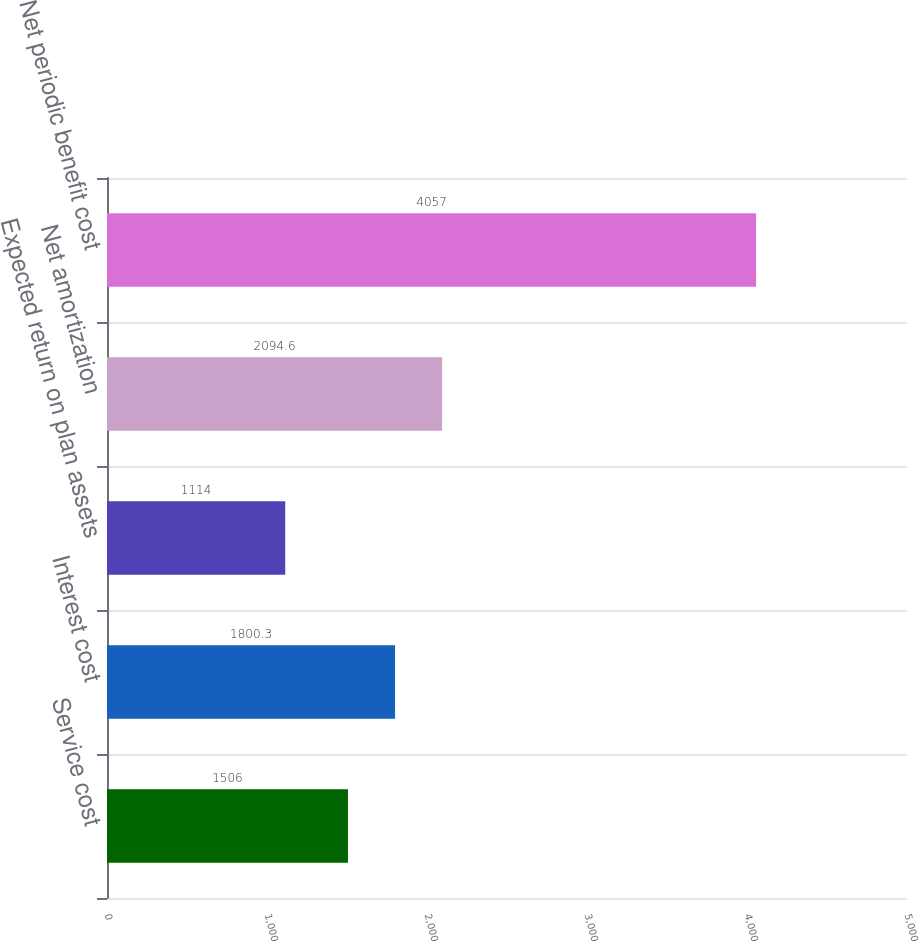Convert chart. <chart><loc_0><loc_0><loc_500><loc_500><bar_chart><fcel>Service cost<fcel>Interest cost<fcel>Expected return on plan assets<fcel>Net amortization<fcel>Net periodic benefit cost<nl><fcel>1506<fcel>1800.3<fcel>1114<fcel>2094.6<fcel>4057<nl></chart> 